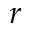<formula> <loc_0><loc_0><loc_500><loc_500>r</formula> 